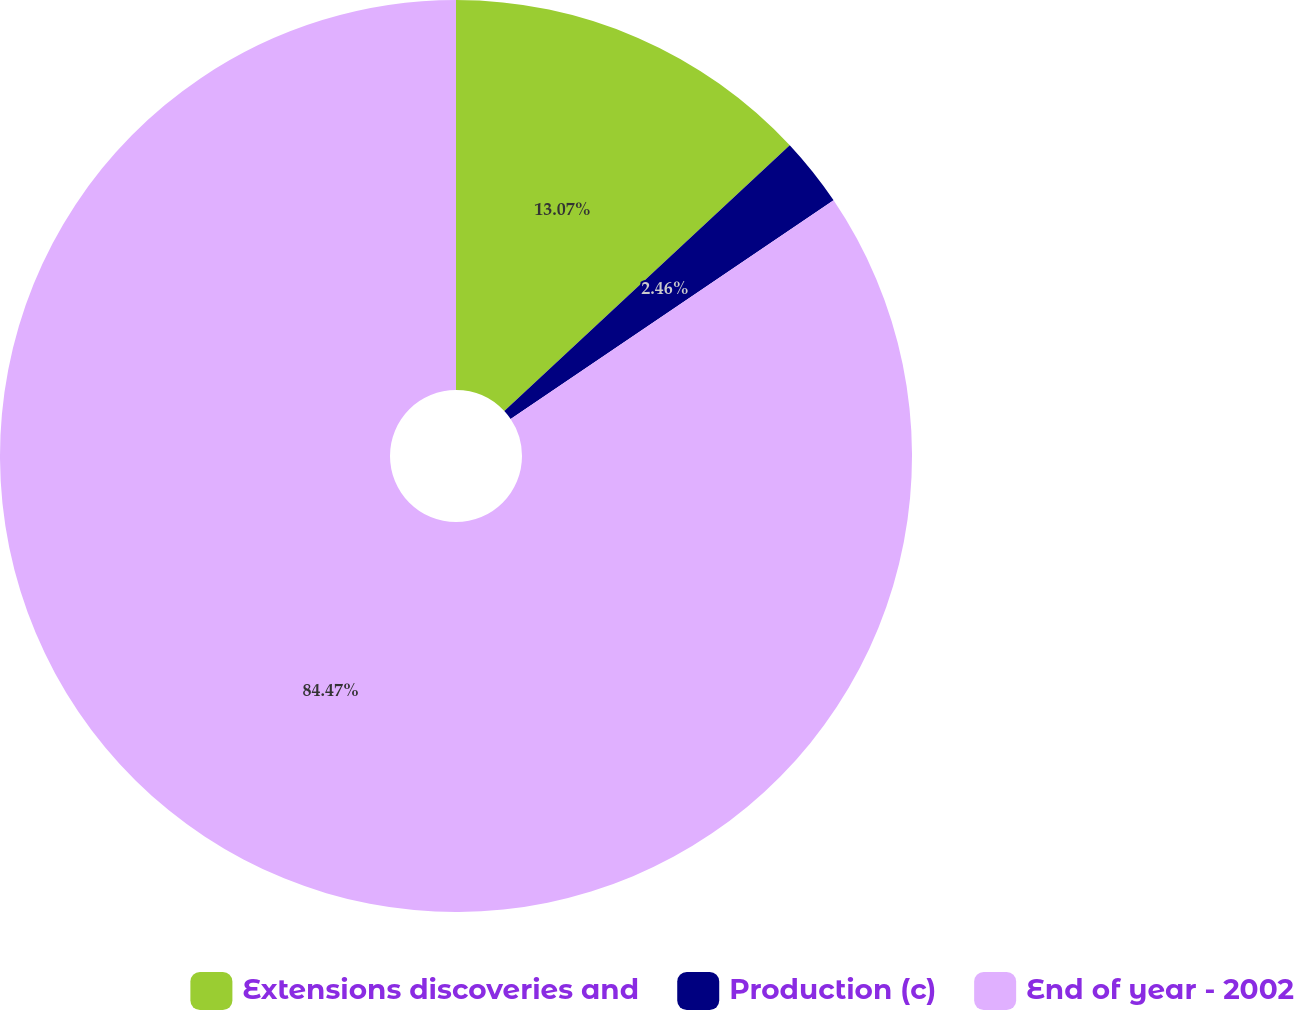Convert chart. <chart><loc_0><loc_0><loc_500><loc_500><pie_chart><fcel>Extensions discoveries and<fcel>Production (c)<fcel>End of year - 2002<nl><fcel>13.07%<fcel>2.46%<fcel>84.48%<nl></chart> 